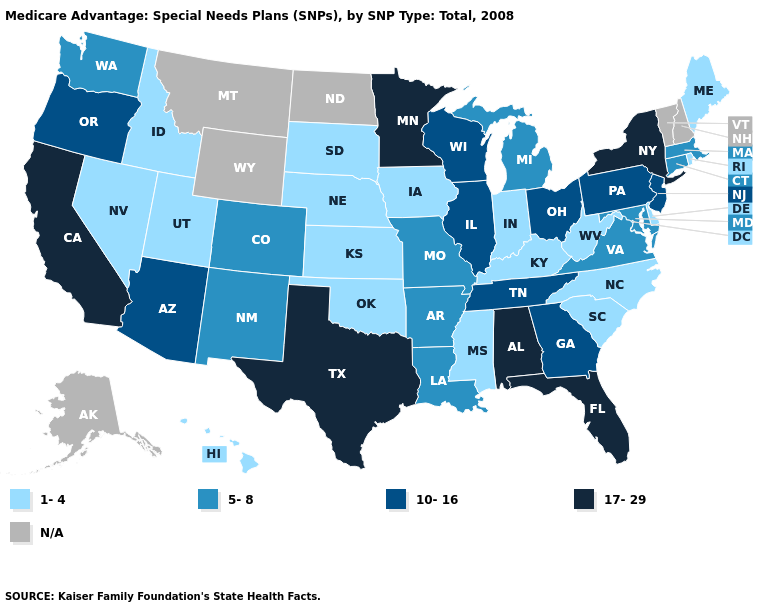Does Iowa have the lowest value in the USA?
Keep it brief. Yes. Name the states that have a value in the range N/A?
Keep it brief. Alaska, Montana, North Dakota, New Hampshire, Vermont, Wyoming. Does the first symbol in the legend represent the smallest category?
Keep it brief. Yes. What is the value of Missouri?
Answer briefly. 5-8. Which states have the lowest value in the MidWest?
Quick response, please. Iowa, Indiana, Kansas, Nebraska, South Dakota. What is the value of New Mexico?
Write a very short answer. 5-8. Among the states that border Connecticut , does Massachusetts have the highest value?
Answer briefly. No. What is the lowest value in the South?
Give a very brief answer. 1-4. Is the legend a continuous bar?
Answer briefly. No. Does the first symbol in the legend represent the smallest category?
Concise answer only. Yes. Name the states that have a value in the range 10-16?
Short answer required. Arizona, Georgia, Illinois, New Jersey, Ohio, Oregon, Pennsylvania, Tennessee, Wisconsin. Name the states that have a value in the range 5-8?
Give a very brief answer. Arkansas, Colorado, Connecticut, Louisiana, Massachusetts, Maryland, Michigan, Missouri, New Mexico, Virginia, Washington. Does the map have missing data?
Give a very brief answer. Yes. 